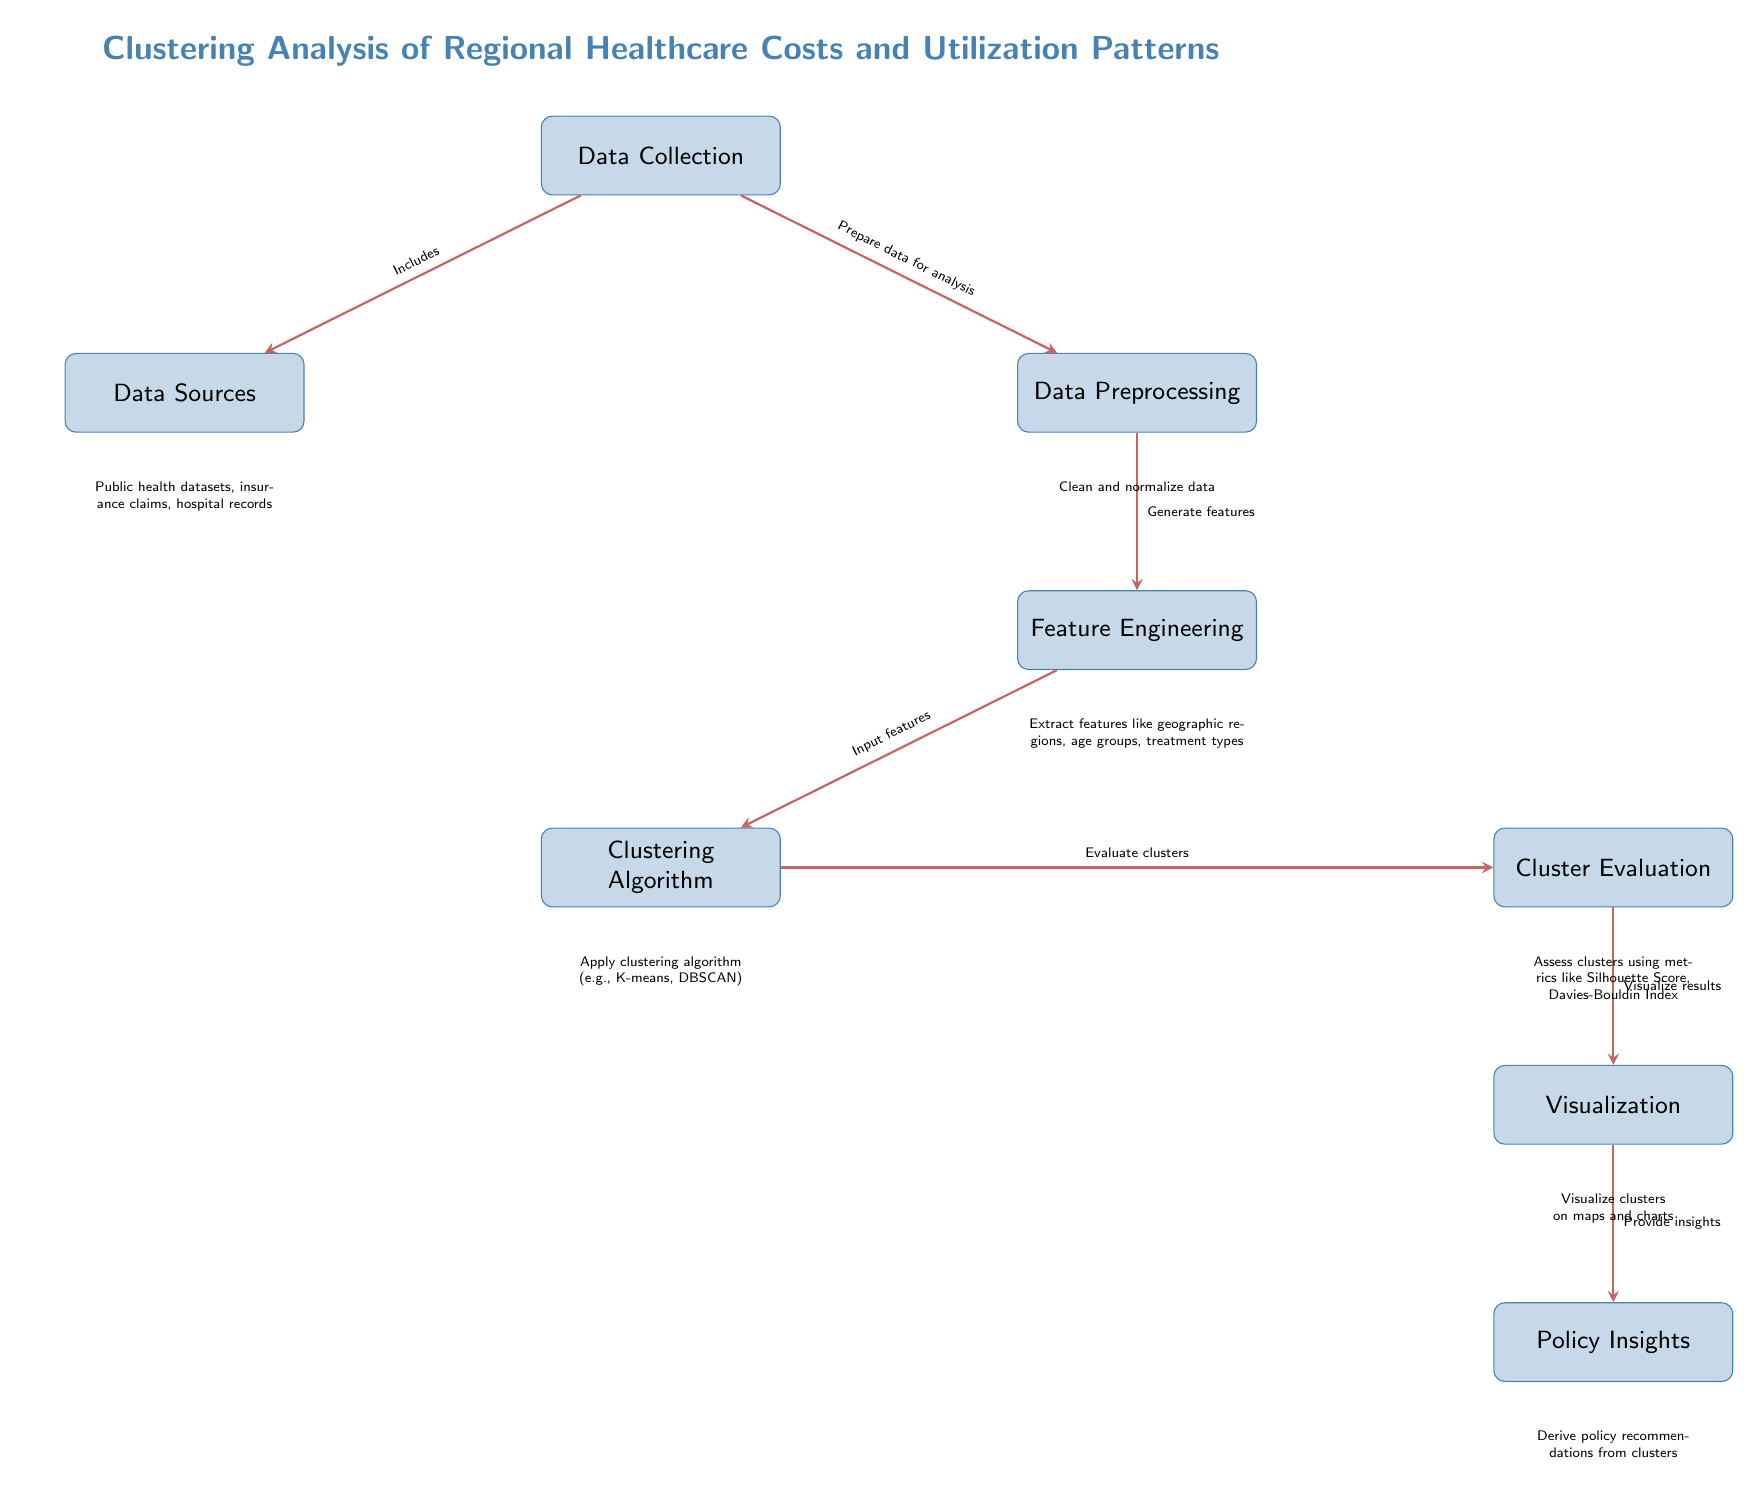What is the first step in the process? The first step in the process, as depicted in the diagram, is "Data Collection." This is indicated as the topmost node.
Answer: Data Collection How many main processes are illustrated in the diagram? The diagram has seven main processes shown as rectangles: Data Collection, Data Sources, Data Preprocessing, Feature Engineering, Clustering Algorithm, Cluster Evaluation, Visualization, and Policy Insights. Counting these gives a total of seven main processes.
Answer: Seven What process follows "Feature Engineering"? Following "Feature Engineering" in the diagram is "Clustering Algorithm," which connects directly below it as the next step in the workflow.
Answer: Clustering Algorithm What type of data sources are listed under "Data Sources"? The data sources listed under this node include public health datasets, insurance claims, and hospital records. These are specifically mentioned in the diagram below the "Data Sources" process.
Answer: Public health datasets, insurance claims, hospital records Which step involves assessing clusters? The step that involves assessing clusters is "Cluster Evaluation." This is shown in the diagram as receiving inputs from the "Clustering Algorithm" and preceding "Visualization."
Answer: Cluster Evaluation What is the purpose of "Visualization"? The purpose of "Visualization" is to provide a way to illustrate the results of the clusters on maps and charts. This is captured in the diagram's description of this process.
Answer: Visualize results How do clusters get evaluated? Clusters are evaluated using metrics such as Silhouette Score and Davies-Bouldin Index, which are mentioned in the diagram below the "Cluster Evaluation" process.
Answer: Metrics like Silhouette Score, Davies-Bouldin Index What is the final output of the analysis? The final output of the analysis is "Policy Insights," as indicated in the diagram, which suggests that recommendations are derived from the insights gained from clustering outcomes.
Answer: Policy Insights 